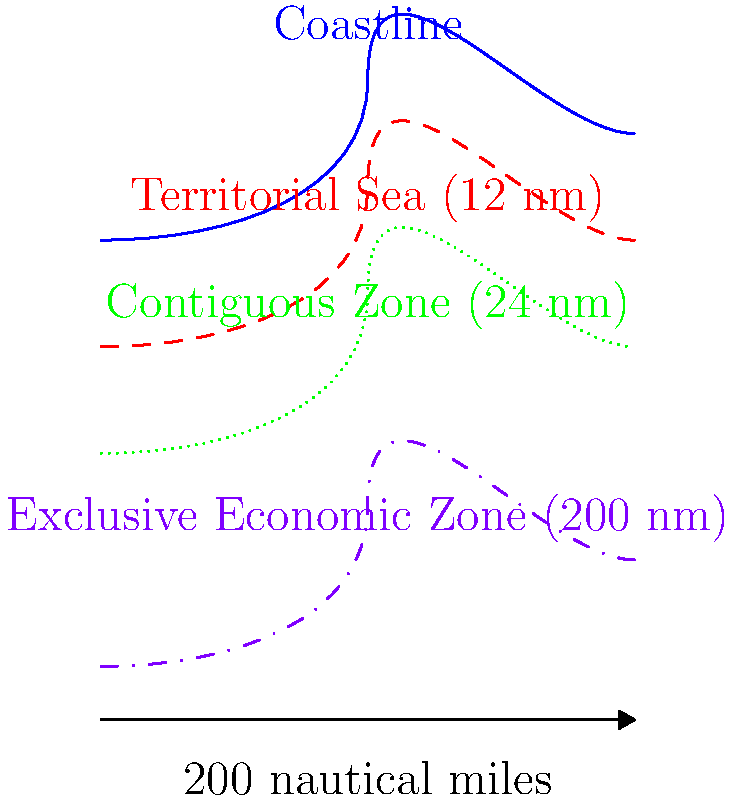Based on the satellite imagery analysis of coastal boundaries, which zone extends up to 24 nautical miles from the baseline and allows a coastal state to prevent infringement of its customs, fiscal, immigration, or sanitary laws? To answer this question, we need to understand the different maritime zones defined by the United Nations Convention on the Law of the Sea (UNCLOS):

1. Territorial Sea: Extends up to 12 nautical miles from the baseline. The coastal state has full sovereignty over this area.

2. Contiguous Zone: Extends up to 24 nautical miles from the baseline. This zone allows the coastal state to prevent infringement of its customs, fiscal, immigration, or sanitary laws.

3. Exclusive Economic Zone (EEZ): Extends up to 200 nautical miles from the baseline. The coastal state has sovereign rights for exploring, exploiting, conserving, and managing natural resources in this area.

In the satellite imagery analysis:
- The blue line represents the coastline (baseline).
- The red dashed line shows the 12 nautical mile limit (Territorial Sea).
- The green dotted line indicates the 24 nautical mile limit (Contiguous Zone).
- The purple dash-dotted line represents the 200 nautical mile limit (EEZ).

The question specifically asks about the zone that extends up to 24 nautical miles and allows the coastal state to prevent infringement of its customs, fiscal, immigration, or sanitary laws. This description matches the Contiguous Zone.
Answer: Contiguous Zone 